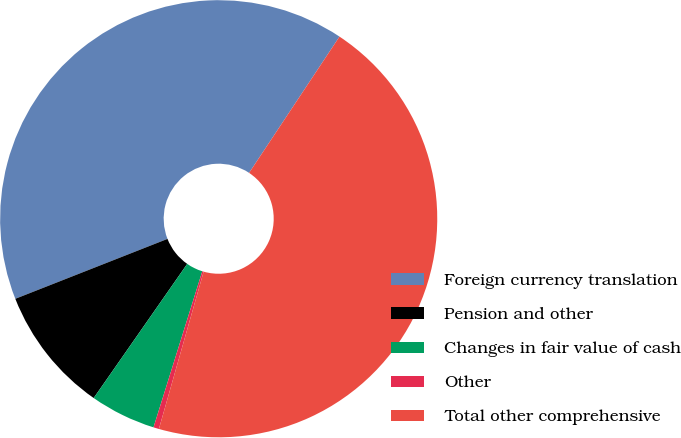Convert chart. <chart><loc_0><loc_0><loc_500><loc_500><pie_chart><fcel>Foreign currency translation<fcel>Pension and other<fcel>Changes in fair value of cash<fcel>Other<fcel>Total other comprehensive<nl><fcel>40.29%<fcel>9.34%<fcel>4.87%<fcel>0.41%<fcel>45.09%<nl></chart> 